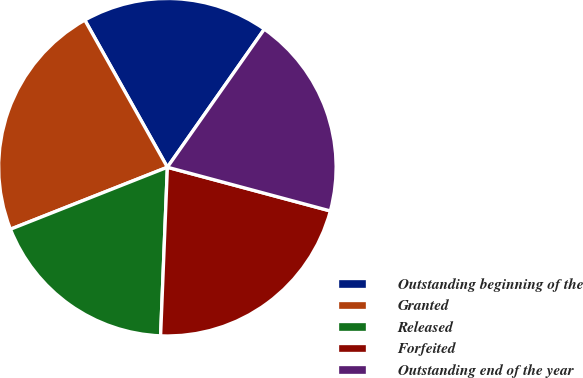Convert chart. <chart><loc_0><loc_0><loc_500><loc_500><pie_chart><fcel>Outstanding beginning of the<fcel>Granted<fcel>Released<fcel>Forfeited<fcel>Outstanding end of the year<nl><fcel>17.88%<fcel>22.85%<fcel>18.37%<fcel>21.47%<fcel>19.43%<nl></chart> 